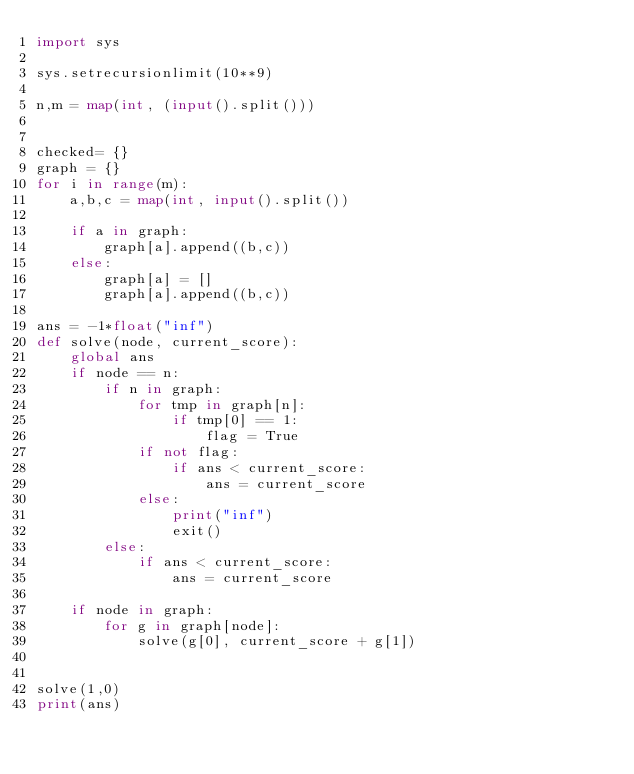<code> <loc_0><loc_0><loc_500><loc_500><_Python_>import sys

sys.setrecursionlimit(10**9)

n,m = map(int, (input().split()))


checked= {}
graph = {}
for i in range(m):
    a,b,c = map(int, input().split())

    if a in graph:
        graph[a].append((b,c))
    else:
        graph[a] = []
        graph[a].append((b,c))

ans = -1*float("inf")
def solve(node, current_score):
    global ans
    if node == n:
        if n in graph:
            for tmp in graph[n]:
                if tmp[0] == 1:
                    flag = True
            if not flag:
                if ans < current_score:
                    ans = current_score 
            else:
                print("inf")
                exit()
        else:
            if ans < current_score:
                ans = current_score 

    if node in graph:
        for g in graph[node]:
            solve(g[0], current_score + g[1])


solve(1,0)
print(ans)</code> 